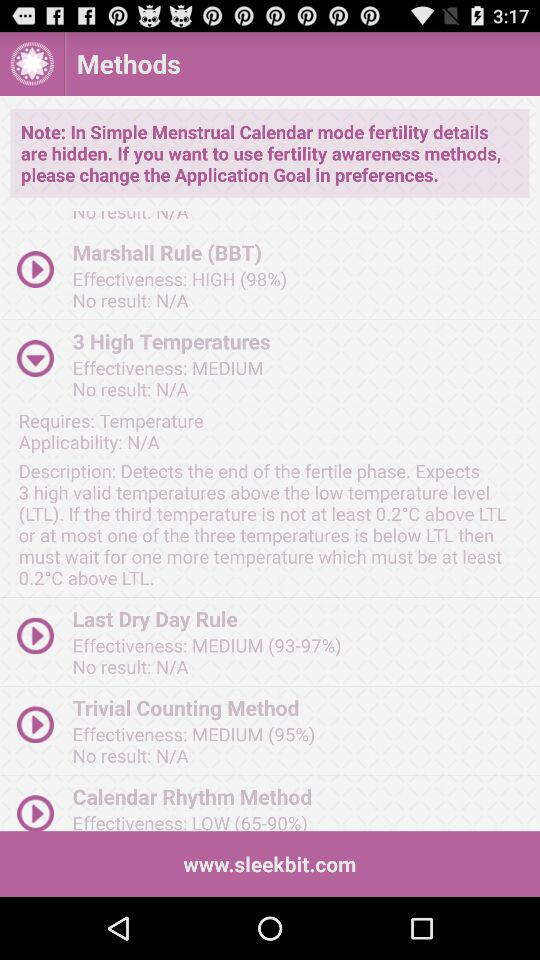What is the effectiveness percentage of the trivial counting method? The effectiveness percentage of the trivial counting method is 95. 